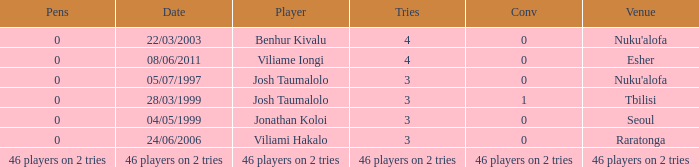What player played on 04/05/1999 with a conv of 0? Jonathan Koloi. 